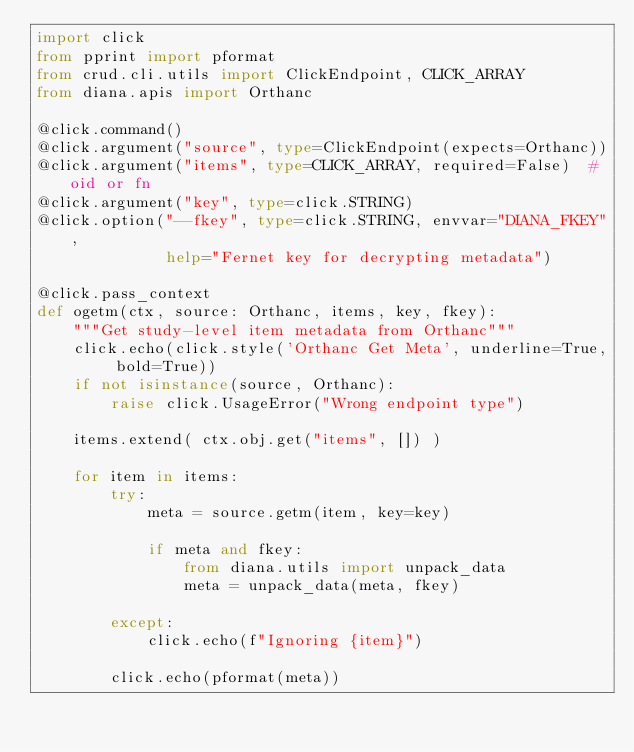<code> <loc_0><loc_0><loc_500><loc_500><_Python_>import click
from pprint import pformat
from crud.cli.utils import ClickEndpoint, CLICK_ARRAY
from diana.apis import Orthanc

@click.command()
@click.argument("source", type=ClickEndpoint(expects=Orthanc))
@click.argument("items", type=CLICK_ARRAY, required=False)  # oid or fn
@click.argument("key", type=click.STRING)
@click.option("--fkey", type=click.STRING, envvar="DIANA_FKEY",
              help="Fernet key for decrypting metadata")

@click.pass_context
def ogetm(ctx, source: Orthanc, items, key, fkey):
    """Get study-level item metadata from Orthanc"""
    click.echo(click.style('Orthanc Get Meta', underline=True, bold=True))
    if not isinstance(source, Orthanc):
        raise click.UsageError("Wrong endpoint type")

    items.extend( ctx.obj.get("items", []) )

    for item in items:
        try:
            meta = source.getm(item, key=key)

            if meta and fkey:
                from diana.utils import unpack_data
                meta = unpack_data(meta, fkey)

        except:
            click.echo(f"Ignoring {item}")

        click.echo(pformat(meta))
</code> 